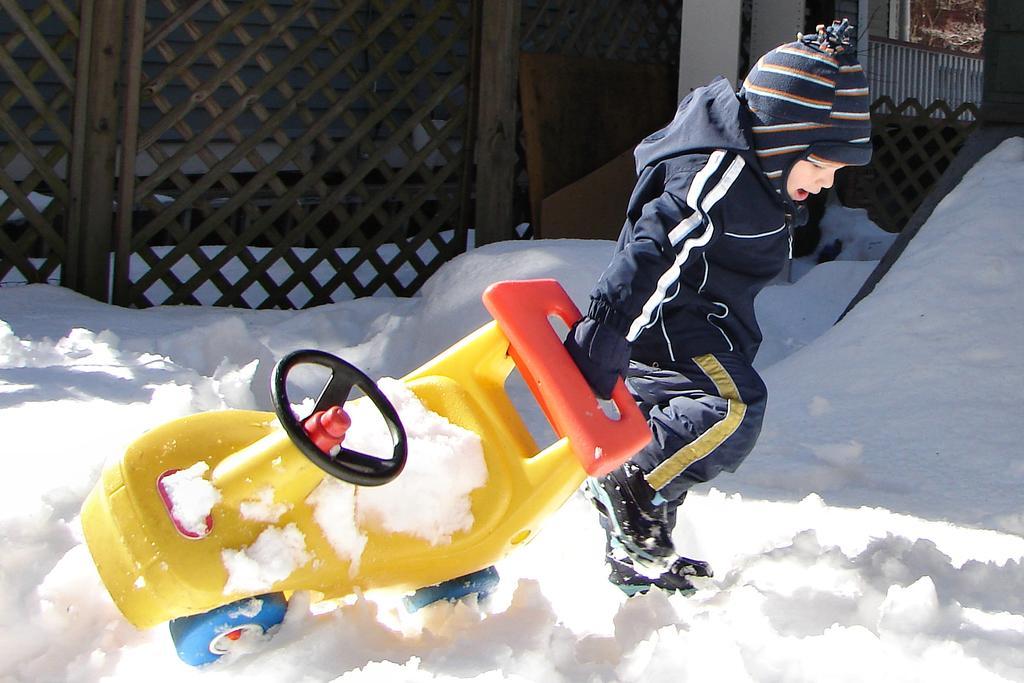Describe this image in one or two sentences. In this image in front there is a boy holding the vehicle. At the bottom of the image there is snow on the surface. Behind him there is a fence. There is a building. 